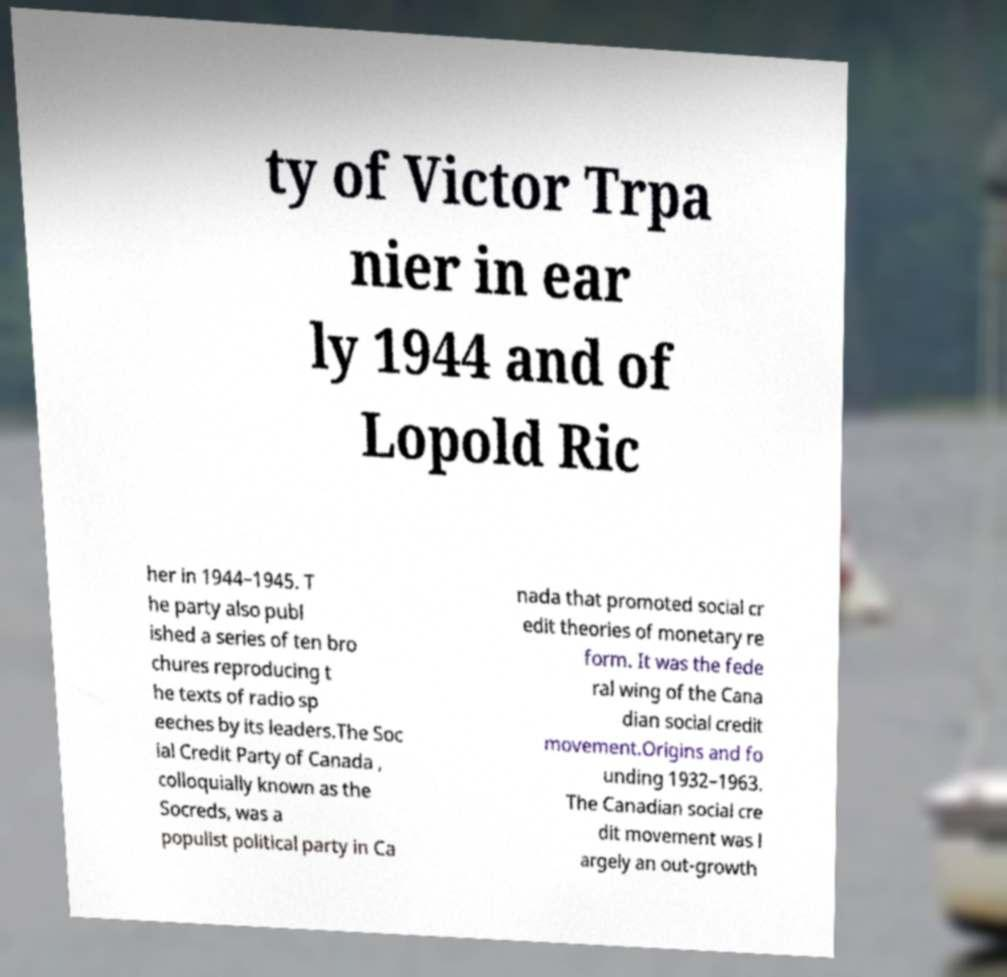What messages or text are displayed in this image? I need them in a readable, typed format. ty of Victor Trpa nier in ear ly 1944 and of Lopold Ric her in 1944–1945. T he party also publ ished a series of ten bro chures reproducing t he texts of radio sp eeches by its leaders.The Soc ial Credit Party of Canada , colloquially known as the Socreds, was a populist political party in Ca nada that promoted social cr edit theories of monetary re form. It was the fede ral wing of the Cana dian social credit movement.Origins and fo unding 1932–1963. The Canadian social cre dit movement was l argely an out-growth 